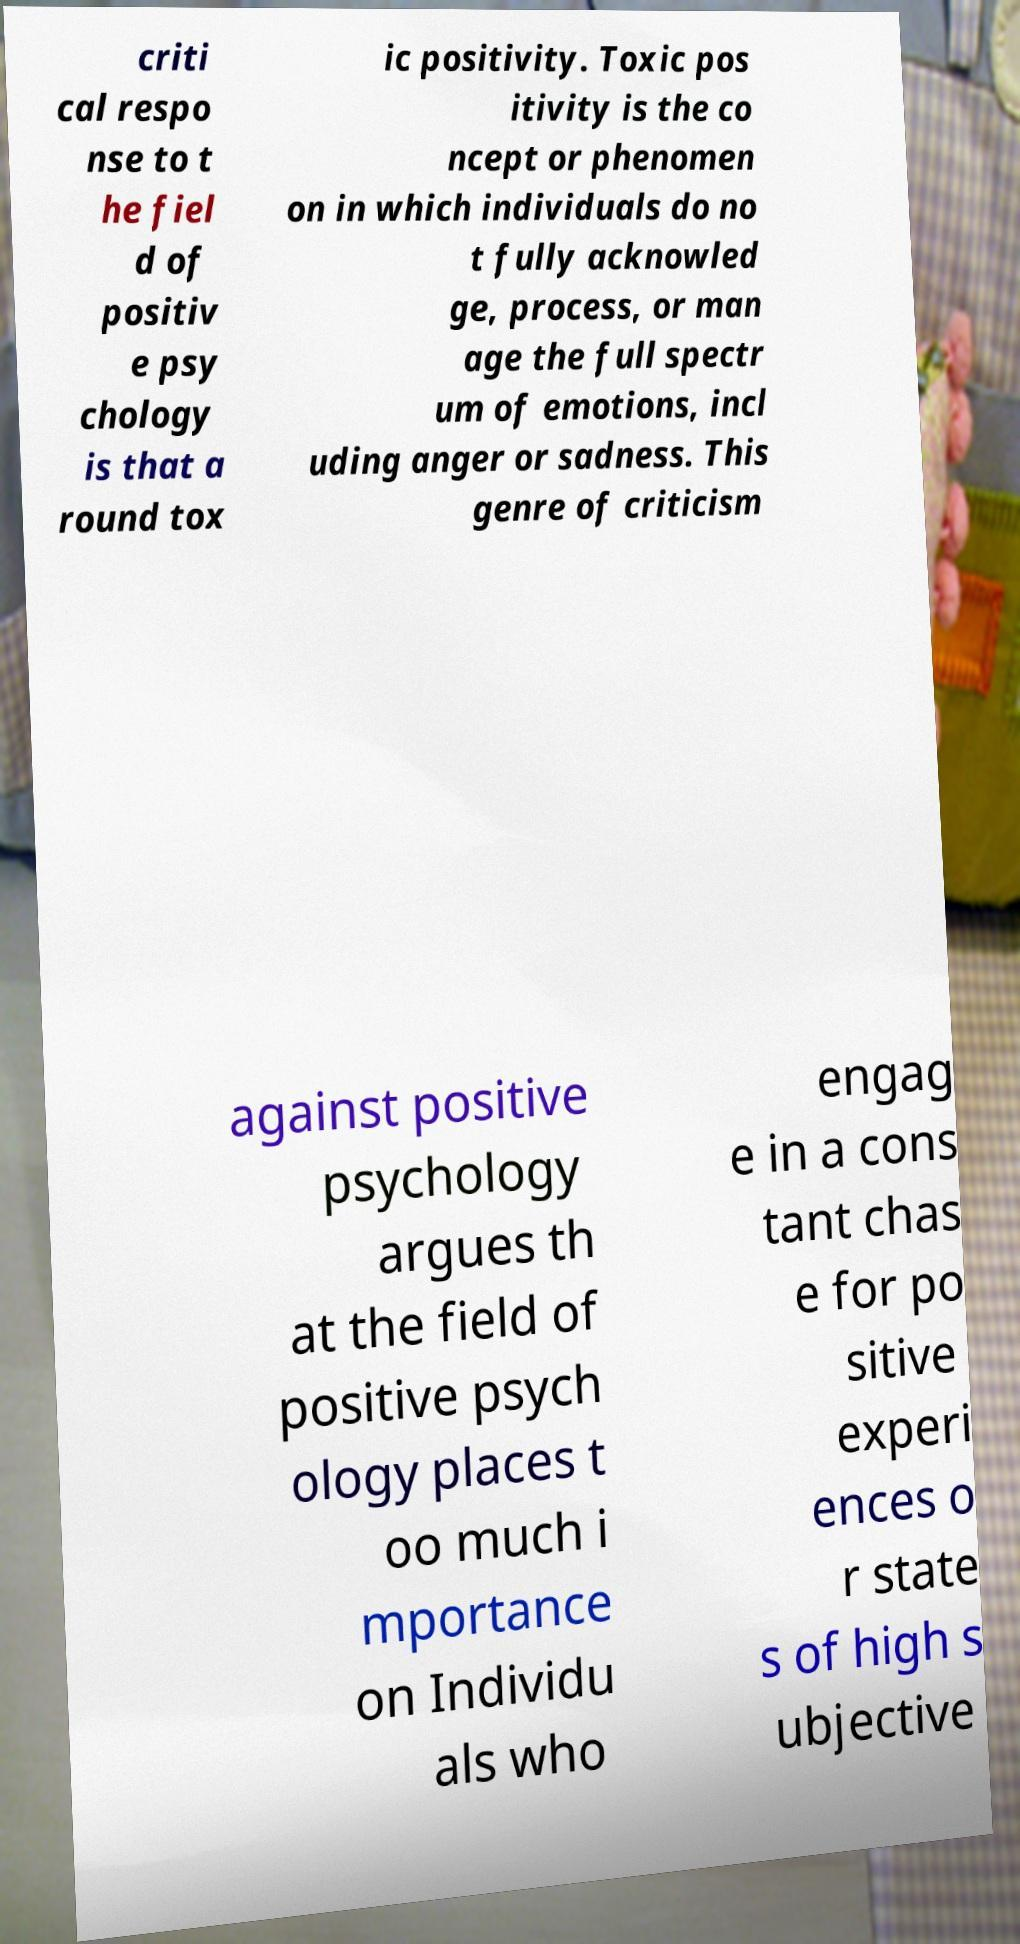I need the written content from this picture converted into text. Can you do that? criti cal respo nse to t he fiel d of positiv e psy chology is that a round tox ic positivity. Toxic pos itivity is the co ncept or phenomen on in which individuals do no t fully acknowled ge, process, or man age the full spectr um of emotions, incl uding anger or sadness. This genre of criticism against positive psychology argues th at the field of positive psych ology places t oo much i mportance on Individu als who engag e in a cons tant chas e for po sitive experi ences o r state s of high s ubjective 